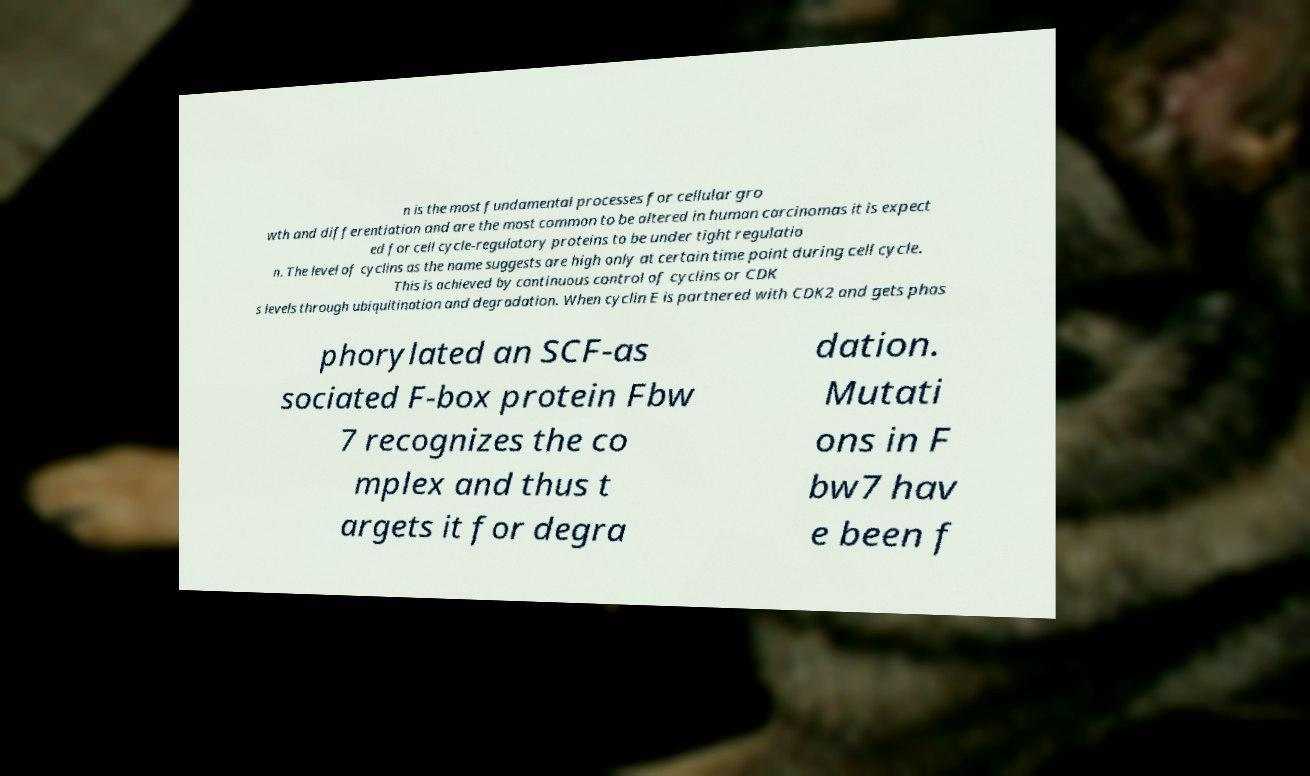Please identify and transcribe the text found in this image. n is the most fundamental processes for cellular gro wth and differentiation and are the most common to be altered in human carcinomas it is expect ed for cell cycle-regulatory proteins to be under tight regulatio n. The level of cyclins as the name suggests are high only at certain time point during cell cycle. This is achieved by continuous control of cyclins or CDK s levels through ubiquitination and degradation. When cyclin E is partnered with CDK2 and gets phos phorylated an SCF-as sociated F-box protein Fbw 7 recognizes the co mplex and thus t argets it for degra dation. Mutati ons in F bw7 hav e been f 